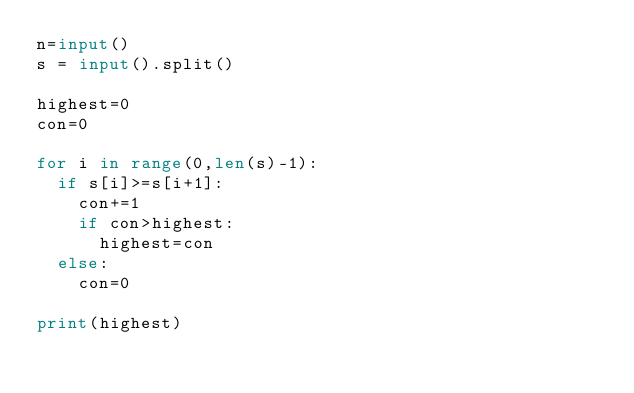<code> <loc_0><loc_0><loc_500><loc_500><_Python_>n=input()
s = input().split()

highest=0
con=0

for i in range(0,len(s)-1):
  if s[i]>=s[i+1]:
    con+=1
    if con>highest:
    	highest=con
  else:
    con=0

print(highest)</code> 